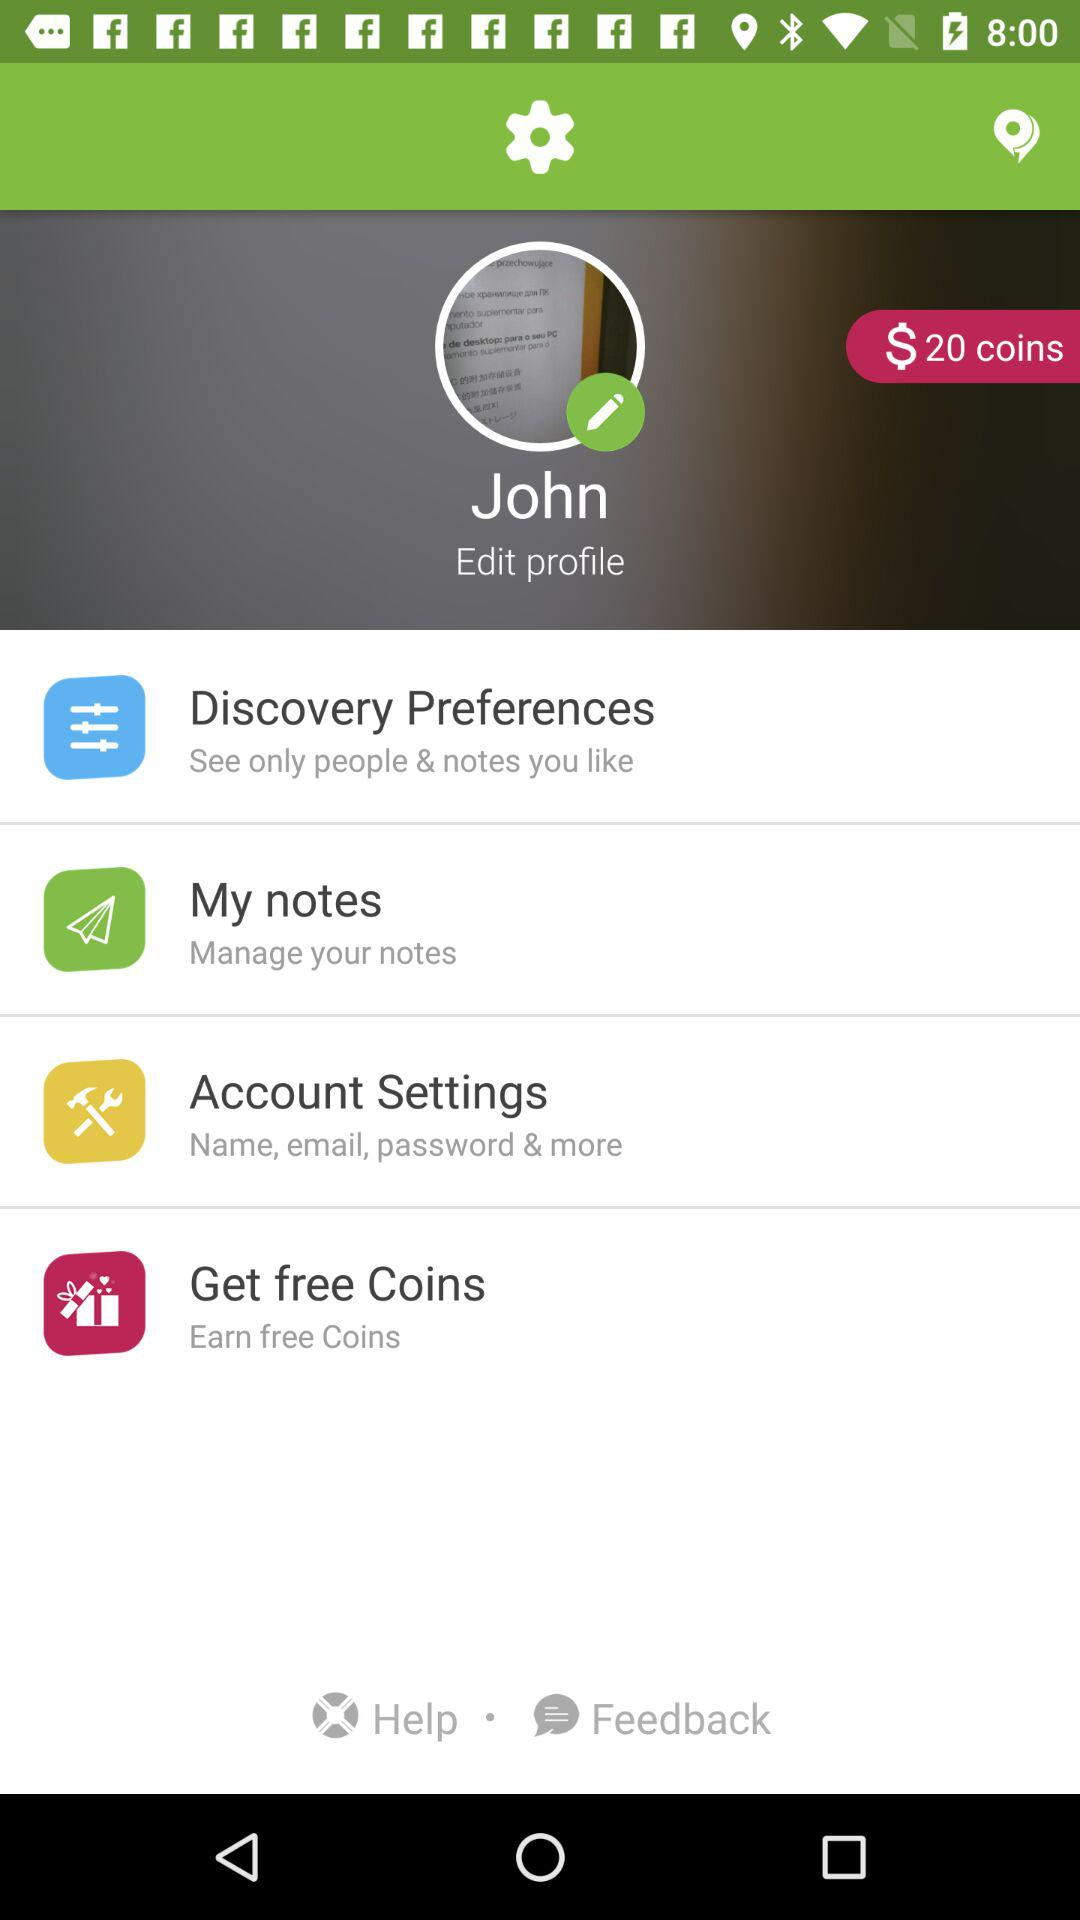How many coins are in the balance? There are $20 coins in the balance. 